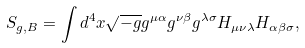<formula> <loc_0><loc_0><loc_500><loc_500>S _ { g , B } = \int { d ^ { 4 } x \sqrt { - g } g ^ { \mu \alpha } g ^ { \nu \beta } g ^ { \lambda \sigma } H _ { \mu \nu \lambda } H _ { \alpha \beta \sigma } } ,</formula> 